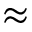Convert formula to latex. <formula><loc_0><loc_0><loc_500><loc_500>\approx</formula> 